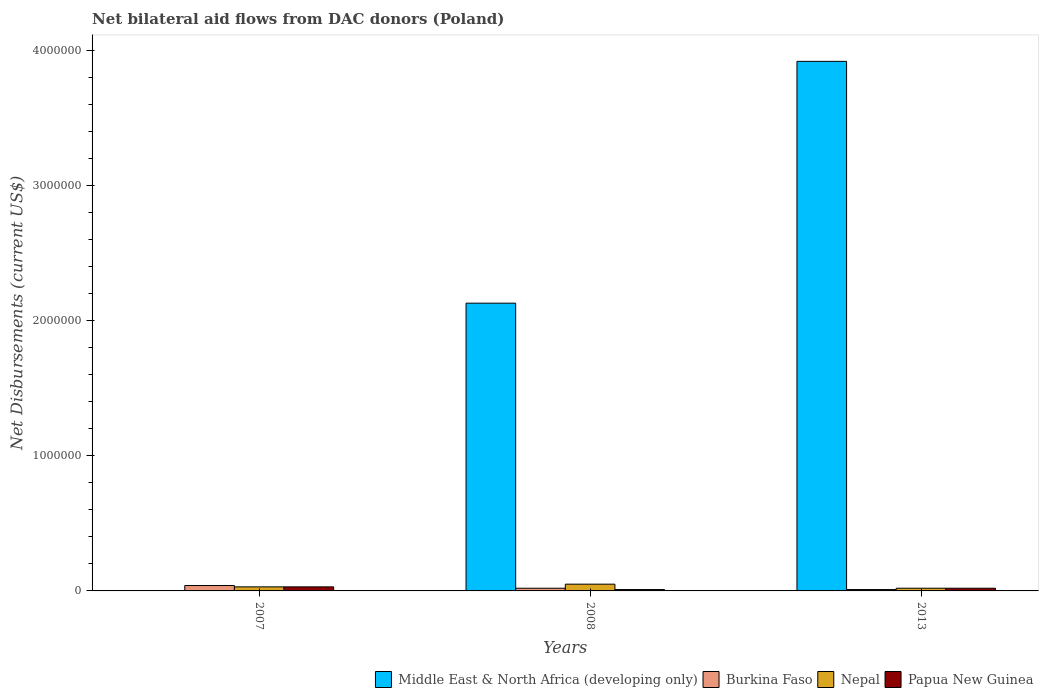How many groups of bars are there?
Ensure brevity in your answer.  3. Are the number of bars per tick equal to the number of legend labels?
Ensure brevity in your answer.  No. How many bars are there on the 2nd tick from the left?
Make the answer very short. 4. Across all years, what is the maximum net bilateral aid flows in Nepal?
Your answer should be very brief. 5.00e+04. Across all years, what is the minimum net bilateral aid flows in Nepal?
Your response must be concise. 2.00e+04. In which year was the net bilateral aid flows in Middle East & North Africa (developing only) maximum?
Ensure brevity in your answer.  2013. What is the total net bilateral aid flows in Middle East & North Africa (developing only) in the graph?
Ensure brevity in your answer.  6.05e+06. What is the difference between the net bilateral aid flows in Middle East & North Africa (developing only) in 2008 and that in 2013?
Your answer should be very brief. -1.79e+06. What is the difference between the net bilateral aid flows in Burkina Faso in 2008 and the net bilateral aid flows in Nepal in 2007?
Offer a very short reply. -10000. What is the average net bilateral aid flows in Burkina Faso per year?
Provide a succinct answer. 2.33e+04. In how many years, is the net bilateral aid flows in Middle East & North Africa (developing only) greater than 1000000 US$?
Ensure brevity in your answer.  2. What is the ratio of the net bilateral aid flows in Burkina Faso in 2008 to that in 2013?
Make the answer very short. 2. Is the net bilateral aid flows in Papua New Guinea in 2008 less than that in 2013?
Ensure brevity in your answer.  Yes. What is the difference between the highest and the second highest net bilateral aid flows in Nepal?
Make the answer very short. 2.00e+04. What is the difference between the highest and the lowest net bilateral aid flows in Middle East & North Africa (developing only)?
Give a very brief answer. 3.92e+06. Is the sum of the net bilateral aid flows in Nepal in 2008 and 2013 greater than the maximum net bilateral aid flows in Burkina Faso across all years?
Ensure brevity in your answer.  Yes. Is it the case that in every year, the sum of the net bilateral aid flows in Papua New Guinea and net bilateral aid flows in Burkina Faso is greater than the sum of net bilateral aid flows in Middle East & North Africa (developing only) and net bilateral aid flows in Nepal?
Offer a very short reply. No. Is it the case that in every year, the sum of the net bilateral aid flows in Burkina Faso and net bilateral aid flows in Nepal is greater than the net bilateral aid flows in Papua New Guinea?
Keep it short and to the point. Yes. Are all the bars in the graph horizontal?
Provide a succinct answer. No. How many years are there in the graph?
Offer a very short reply. 3. What is the difference between two consecutive major ticks on the Y-axis?
Your response must be concise. 1.00e+06. Does the graph contain any zero values?
Keep it short and to the point. Yes. Where does the legend appear in the graph?
Offer a very short reply. Bottom right. How many legend labels are there?
Your answer should be compact. 4. How are the legend labels stacked?
Offer a terse response. Horizontal. What is the title of the graph?
Provide a succinct answer. Net bilateral aid flows from DAC donors (Poland). Does "Philippines" appear as one of the legend labels in the graph?
Keep it short and to the point. No. What is the label or title of the X-axis?
Make the answer very short. Years. What is the label or title of the Y-axis?
Provide a short and direct response. Net Disbursements (current US$). What is the Net Disbursements (current US$) in Middle East & North Africa (developing only) in 2007?
Offer a very short reply. 0. What is the Net Disbursements (current US$) in Nepal in 2007?
Make the answer very short. 3.00e+04. What is the Net Disbursements (current US$) of Middle East & North Africa (developing only) in 2008?
Your answer should be compact. 2.13e+06. What is the Net Disbursements (current US$) in Papua New Guinea in 2008?
Keep it short and to the point. 10000. What is the Net Disbursements (current US$) of Middle East & North Africa (developing only) in 2013?
Offer a very short reply. 3.92e+06. What is the Net Disbursements (current US$) of Papua New Guinea in 2013?
Offer a very short reply. 2.00e+04. Across all years, what is the maximum Net Disbursements (current US$) of Middle East & North Africa (developing only)?
Offer a very short reply. 3.92e+06. Across all years, what is the maximum Net Disbursements (current US$) of Burkina Faso?
Your response must be concise. 4.00e+04. Across all years, what is the maximum Net Disbursements (current US$) in Papua New Guinea?
Offer a very short reply. 3.00e+04. Across all years, what is the minimum Net Disbursements (current US$) of Middle East & North Africa (developing only)?
Make the answer very short. 0. Across all years, what is the minimum Net Disbursements (current US$) in Papua New Guinea?
Provide a short and direct response. 10000. What is the total Net Disbursements (current US$) in Middle East & North Africa (developing only) in the graph?
Keep it short and to the point. 6.05e+06. What is the total Net Disbursements (current US$) in Nepal in the graph?
Provide a short and direct response. 1.00e+05. What is the total Net Disbursements (current US$) in Papua New Guinea in the graph?
Your answer should be compact. 6.00e+04. What is the difference between the Net Disbursements (current US$) of Papua New Guinea in 2007 and that in 2008?
Make the answer very short. 2.00e+04. What is the difference between the Net Disbursements (current US$) in Burkina Faso in 2007 and that in 2013?
Give a very brief answer. 3.00e+04. What is the difference between the Net Disbursements (current US$) of Nepal in 2007 and that in 2013?
Offer a terse response. 10000. What is the difference between the Net Disbursements (current US$) of Middle East & North Africa (developing only) in 2008 and that in 2013?
Your answer should be very brief. -1.79e+06. What is the difference between the Net Disbursements (current US$) in Burkina Faso in 2008 and that in 2013?
Provide a succinct answer. 10000. What is the difference between the Net Disbursements (current US$) in Nepal in 2008 and that in 2013?
Your answer should be compact. 3.00e+04. What is the difference between the Net Disbursements (current US$) of Burkina Faso in 2007 and the Net Disbursements (current US$) of Papua New Guinea in 2008?
Provide a succinct answer. 3.00e+04. What is the difference between the Net Disbursements (current US$) in Nepal in 2007 and the Net Disbursements (current US$) in Papua New Guinea in 2008?
Your answer should be very brief. 2.00e+04. What is the difference between the Net Disbursements (current US$) in Burkina Faso in 2007 and the Net Disbursements (current US$) in Nepal in 2013?
Your answer should be compact. 2.00e+04. What is the difference between the Net Disbursements (current US$) of Burkina Faso in 2007 and the Net Disbursements (current US$) of Papua New Guinea in 2013?
Your response must be concise. 2.00e+04. What is the difference between the Net Disbursements (current US$) of Nepal in 2007 and the Net Disbursements (current US$) of Papua New Guinea in 2013?
Provide a short and direct response. 10000. What is the difference between the Net Disbursements (current US$) in Middle East & North Africa (developing only) in 2008 and the Net Disbursements (current US$) in Burkina Faso in 2013?
Ensure brevity in your answer.  2.12e+06. What is the difference between the Net Disbursements (current US$) in Middle East & North Africa (developing only) in 2008 and the Net Disbursements (current US$) in Nepal in 2013?
Keep it short and to the point. 2.11e+06. What is the difference between the Net Disbursements (current US$) of Middle East & North Africa (developing only) in 2008 and the Net Disbursements (current US$) of Papua New Guinea in 2013?
Offer a very short reply. 2.11e+06. What is the difference between the Net Disbursements (current US$) of Burkina Faso in 2008 and the Net Disbursements (current US$) of Papua New Guinea in 2013?
Provide a short and direct response. 0. What is the average Net Disbursements (current US$) in Middle East & North Africa (developing only) per year?
Offer a terse response. 2.02e+06. What is the average Net Disbursements (current US$) of Burkina Faso per year?
Give a very brief answer. 2.33e+04. What is the average Net Disbursements (current US$) of Nepal per year?
Ensure brevity in your answer.  3.33e+04. In the year 2007, what is the difference between the Net Disbursements (current US$) of Burkina Faso and Net Disbursements (current US$) of Papua New Guinea?
Keep it short and to the point. 10000. In the year 2007, what is the difference between the Net Disbursements (current US$) of Nepal and Net Disbursements (current US$) of Papua New Guinea?
Offer a very short reply. 0. In the year 2008, what is the difference between the Net Disbursements (current US$) in Middle East & North Africa (developing only) and Net Disbursements (current US$) in Burkina Faso?
Make the answer very short. 2.11e+06. In the year 2008, what is the difference between the Net Disbursements (current US$) in Middle East & North Africa (developing only) and Net Disbursements (current US$) in Nepal?
Offer a terse response. 2.08e+06. In the year 2008, what is the difference between the Net Disbursements (current US$) in Middle East & North Africa (developing only) and Net Disbursements (current US$) in Papua New Guinea?
Your answer should be very brief. 2.12e+06. In the year 2008, what is the difference between the Net Disbursements (current US$) of Burkina Faso and Net Disbursements (current US$) of Nepal?
Keep it short and to the point. -3.00e+04. In the year 2013, what is the difference between the Net Disbursements (current US$) in Middle East & North Africa (developing only) and Net Disbursements (current US$) in Burkina Faso?
Provide a succinct answer. 3.91e+06. In the year 2013, what is the difference between the Net Disbursements (current US$) of Middle East & North Africa (developing only) and Net Disbursements (current US$) of Nepal?
Give a very brief answer. 3.90e+06. In the year 2013, what is the difference between the Net Disbursements (current US$) in Middle East & North Africa (developing only) and Net Disbursements (current US$) in Papua New Guinea?
Your answer should be very brief. 3.90e+06. In the year 2013, what is the difference between the Net Disbursements (current US$) in Burkina Faso and Net Disbursements (current US$) in Nepal?
Provide a succinct answer. -10000. In the year 2013, what is the difference between the Net Disbursements (current US$) of Burkina Faso and Net Disbursements (current US$) of Papua New Guinea?
Offer a terse response. -10000. What is the ratio of the Net Disbursements (current US$) of Burkina Faso in 2007 to that in 2008?
Make the answer very short. 2. What is the ratio of the Net Disbursements (current US$) in Nepal in 2007 to that in 2008?
Your answer should be very brief. 0.6. What is the ratio of the Net Disbursements (current US$) of Burkina Faso in 2007 to that in 2013?
Your response must be concise. 4. What is the ratio of the Net Disbursements (current US$) of Nepal in 2007 to that in 2013?
Provide a short and direct response. 1.5. What is the ratio of the Net Disbursements (current US$) in Middle East & North Africa (developing only) in 2008 to that in 2013?
Provide a short and direct response. 0.54. What is the ratio of the Net Disbursements (current US$) in Nepal in 2008 to that in 2013?
Ensure brevity in your answer.  2.5. What is the ratio of the Net Disbursements (current US$) of Papua New Guinea in 2008 to that in 2013?
Provide a succinct answer. 0.5. What is the difference between the highest and the second highest Net Disbursements (current US$) in Nepal?
Your answer should be compact. 2.00e+04. What is the difference between the highest and the lowest Net Disbursements (current US$) of Middle East & North Africa (developing only)?
Your answer should be compact. 3.92e+06. 